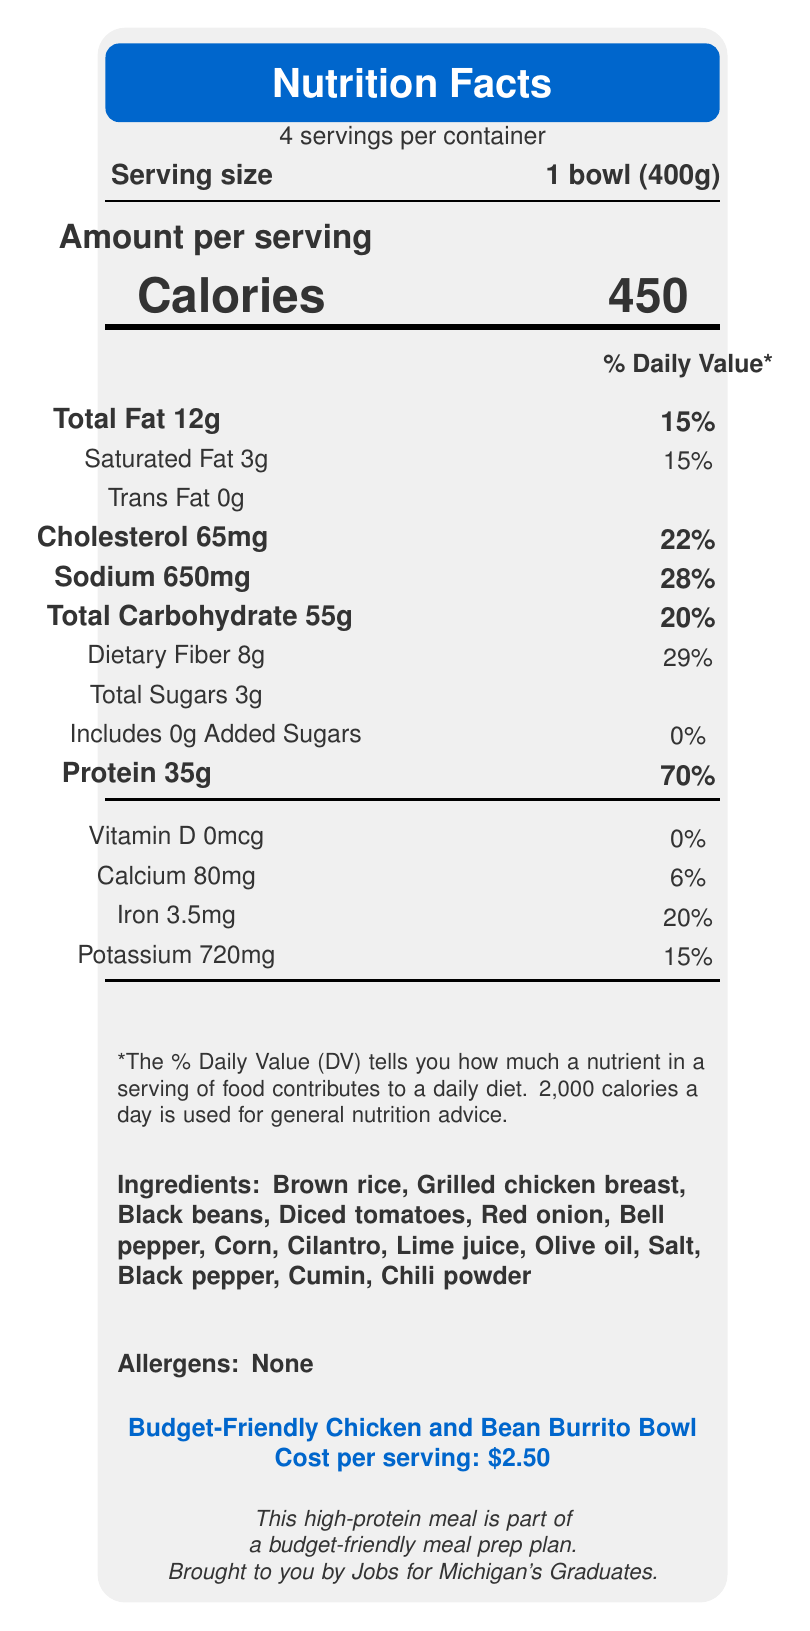how many servings are in the container? The document states "4 servings per container."
Answer: 4 what is the serving size in grams? The document specifies the serving size as "1 bowl (400g)."
Answer: 400g how many calories per serving? The document lists the amount of calories as 450 under "Calories."
Answer: 450 what is the total fat content per serving? The document shows "Total Fat 12g" in the nutrition facts.
Answer: 12g how much protein is in one serving? The nutrition facts state "Protein 35g."
Answer: 35g what is the daily value percentage for dietary fiber? A. 20% B. 25% C. 29% D. 30% The document lists "Dietary Fiber 8g" and "29%" as the daily value percentage.
Answer: C what is the cost per serving? A. $1.50 B. $2.50 C. $3.50 D. $4.50 The document shows "Cost per serving: $2.50."
Answer: B are there any added sugars in the meal? The document specifies "Includes 0g Added Sugars."
Answer: No does the meal contain any allergens? The document lists "Allergens: None."
Answer: No describe the purpose of this document The document highlights the nutritional facts for a high-protein meal prep recipe, mentions its ingredients and cost, and emphasizes its benefits and preparation tips.
Answer: To present nutritional information about the Budget-Friendly Chicken and Bean Burrito Bowl, including ingredients, allergens, preparation tips, cost per serving, and various nutritional values based on a 2000 calorie diet. how easily can the vegetables be prepped for this meal? The preparation tips recommend prepping vegetables ahead of time for quick assembly, indicating ease of preparation.
Answer: Easily, as the document suggests prepping vegetables in advance for quick assembly. how much sodium is in each serving? The document lists "Sodium 650mg" in the nutrition facts.
Answer: 650mg what are the benefits of this meal? The document outlines benefits such as high protein, rich fiber content, complex carbohydrates, affordability, and customization options.
Answer: High in protein, rich in fiber, contains complex carbohydrates, affordable, customizable how much potassium is in each serving? The nutrition facts section lists "Potassium 720mg."
Answer: 720mg is this meal balanced in terms of macronutrients? The document states that the meal is balanced with protein, carbs, and healthy fats for optimal nutrition.
Answer: Yes how much vitamin D is in the meal? The document lists "Vitamin D 0mcg."
Answer: 0mcg what are the preparation tips for this meal? The document provides detailed preparation tips such as cooking in bulk, using canned ingredients, prepping vegetables, and storage recommendations.
Answer: Cook rice and chicken in bulk, use canned beans and corn, prep vegetables in advance, store in airtight containers, can be eaten cold or reheated. does this meal help in saving money and time? The document indicates that meal prepping can help save money and time while ensuring nutritious meals.
Answer: Yes what percentage of daily value does the meal provide for calcium? The document lists "Calcium 80mg" with a daily value percentage of 6%.
Answer: 6% how much cholesterol is in one serving? The document specifies "Cholesterol 65mg."
Answer: 65mg can this document tell us how to cook the chicken? The document lists nutritional facts, ingredients, and preparation tips but does not provide specific cooking instructions for chicken.
Answer: Not enough information are there any complex carbohydrates in the meal? The document states that the meal contains complex carbohydrates for sustained energy.
Answer: Yes 